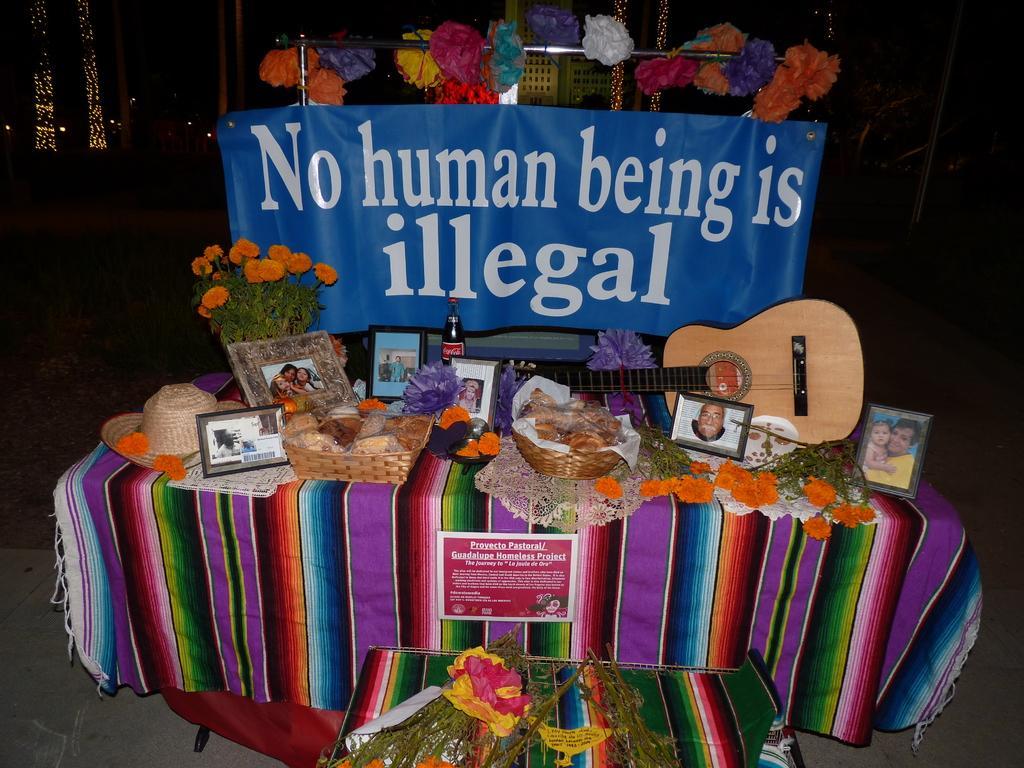How would you summarize this image in a sentence or two? In this image I can see few food items, frames, few flowers and the musical instrument on the multi color cloth. In the background I can see the banner in blue color and I can also see few decorative items and few lights. 